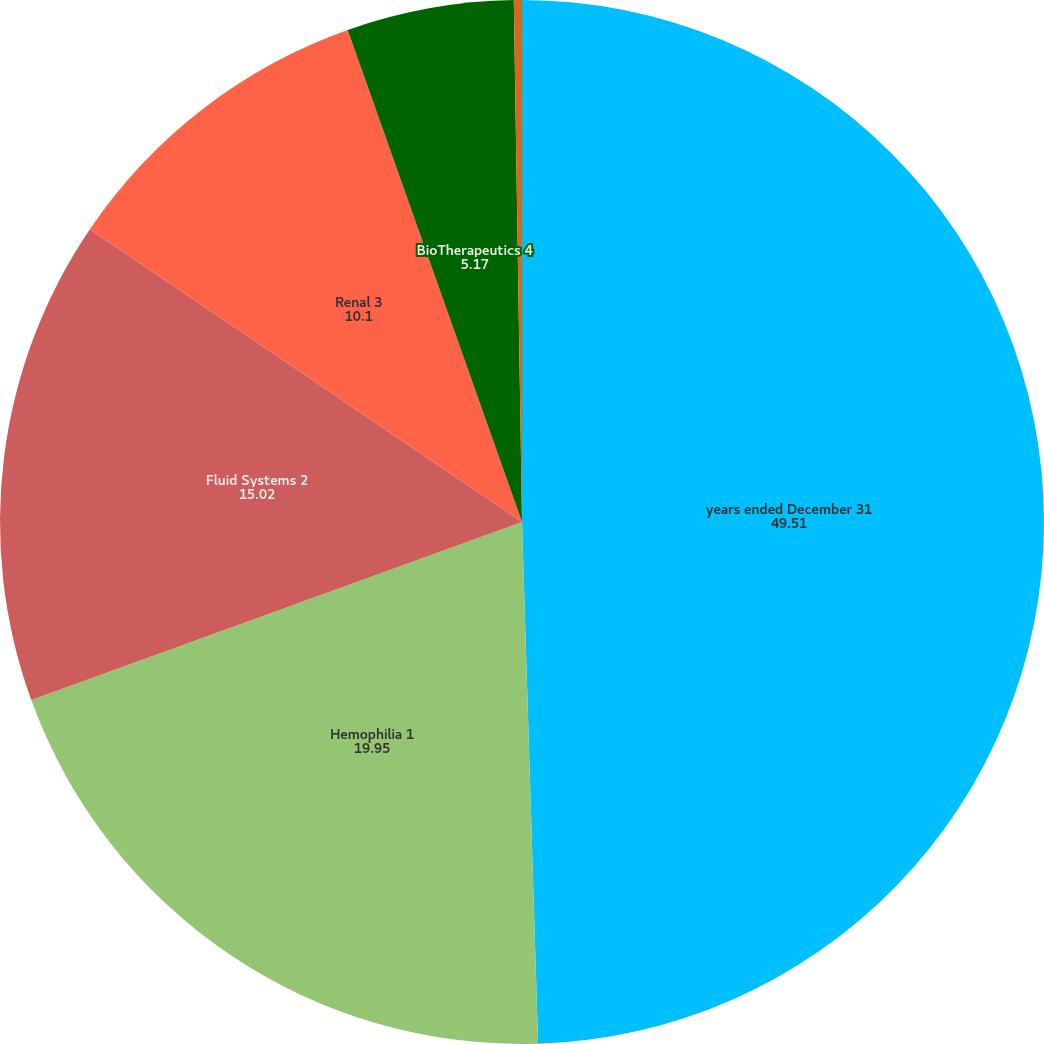Convert chart to OTSL. <chart><loc_0><loc_0><loc_500><loc_500><pie_chart><fcel>years ended December 31<fcel>Hemophilia 1<fcel>Fluid Systems 2<fcel>Renal 3<fcel>BioTherapeutics 4<fcel>Specialty Pharmaceuticals 5<nl><fcel>49.51%<fcel>19.95%<fcel>15.02%<fcel>10.1%<fcel>5.17%<fcel>0.25%<nl></chart> 